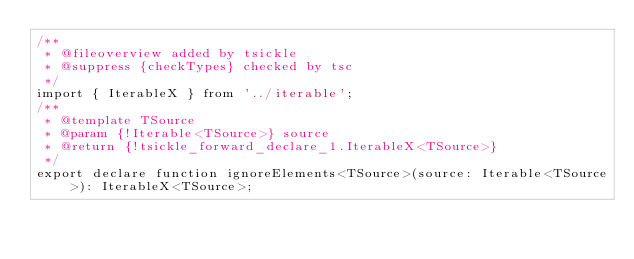<code> <loc_0><loc_0><loc_500><loc_500><_TypeScript_>/**
 * @fileoverview added by tsickle
 * @suppress {checkTypes} checked by tsc
 */
import { IterableX } from '../iterable';
/**
 * @template TSource
 * @param {!Iterable<TSource>} source
 * @return {!tsickle_forward_declare_1.IterableX<TSource>}
 */
export declare function ignoreElements<TSource>(source: Iterable<TSource>): IterableX<TSource>;
</code> 